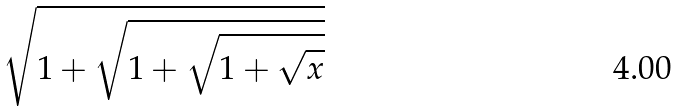<formula> <loc_0><loc_0><loc_500><loc_500>\sqrt { 1 + \sqrt { 1 + \sqrt { 1 + \sqrt { x } } } }</formula> 